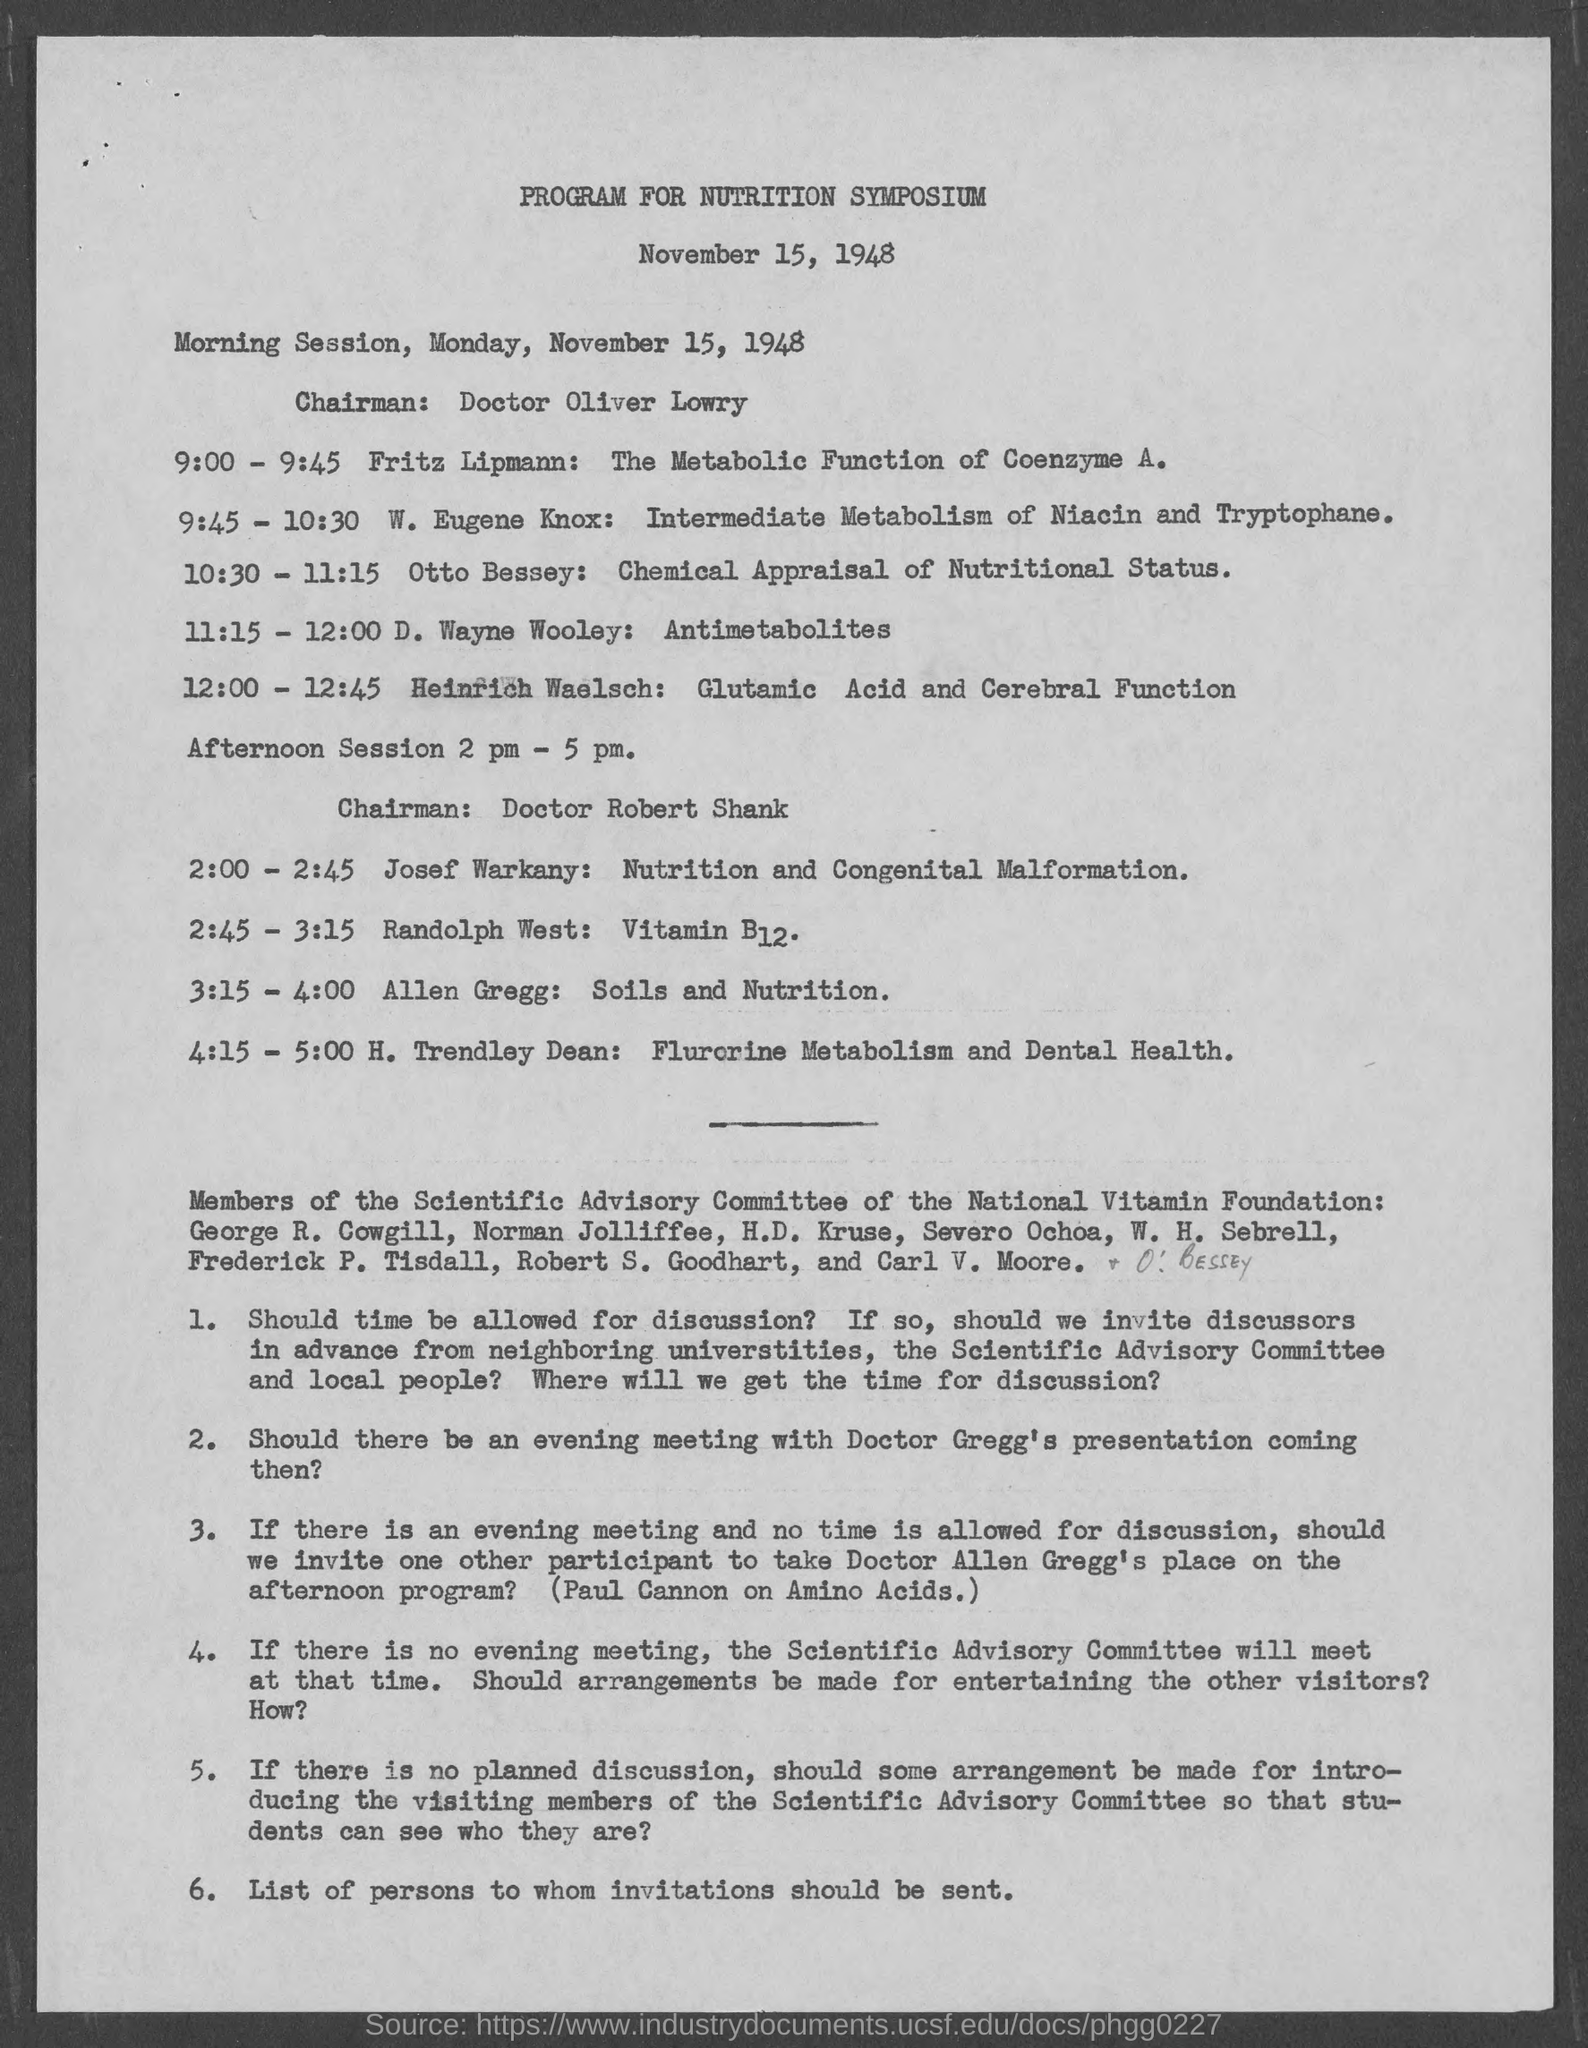When is the Nutrition Symposium held?
Keep it short and to the point. November 15, 1948. Who is the chairman for the morning session?
Provide a succinct answer. Doctor Oliver Lowry. What time is the session 'D. Wayne Wooley: Antimetabolites' held on Monday, November 15, 1948?
Make the answer very short. 11:15 - 12:00. When is the afternoon sessions held?
Your answer should be very brief. 2 pm - 5 pm. Who is the chairman for the afternoon sessions?
Make the answer very short. Doctor Robert Shank. 